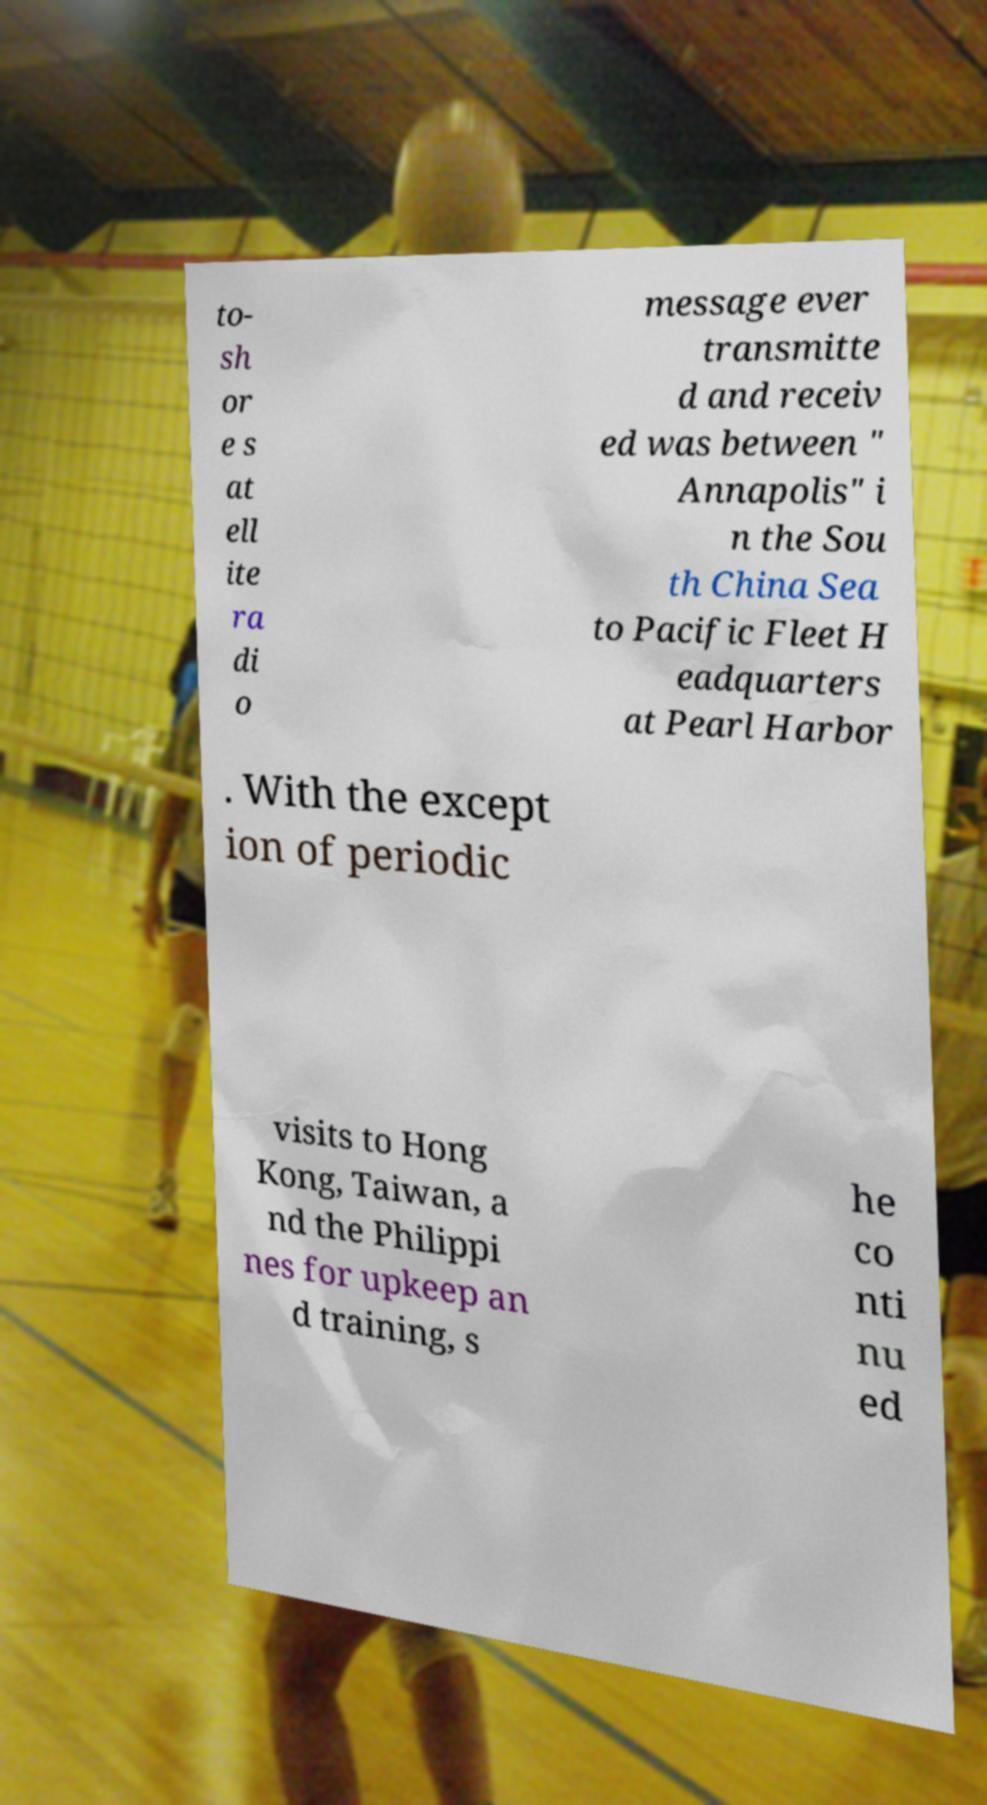Could you assist in decoding the text presented in this image and type it out clearly? to- sh or e s at ell ite ra di o message ever transmitte d and receiv ed was between " Annapolis" i n the Sou th China Sea to Pacific Fleet H eadquarters at Pearl Harbor . With the except ion of periodic visits to Hong Kong, Taiwan, a nd the Philippi nes for upkeep an d training, s he co nti nu ed 